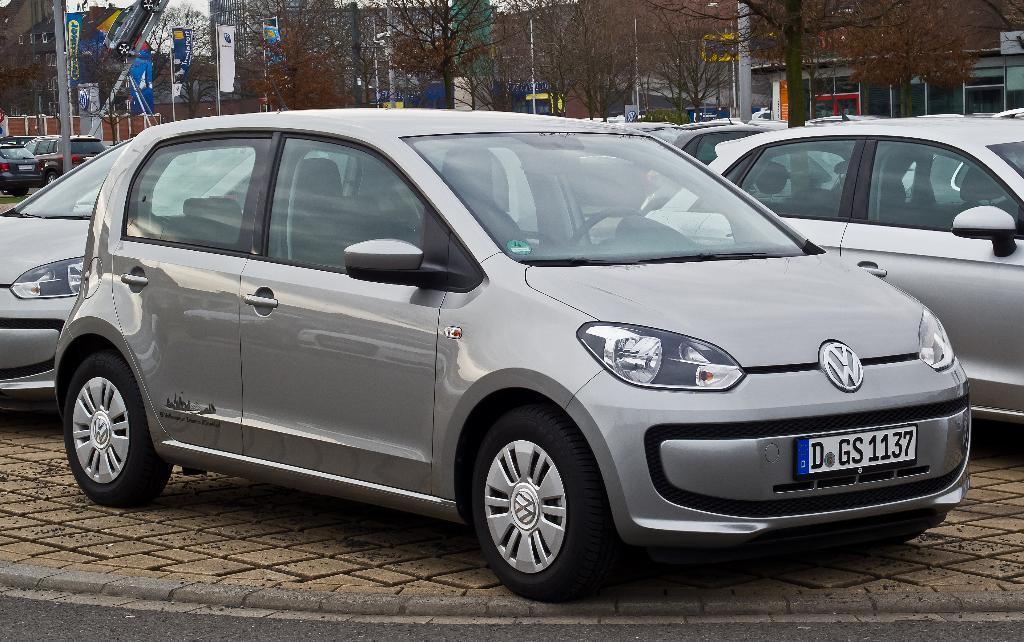How would you summarize this image in a sentence or two? In this image I can see few vehicles. In the background I can see few banners attached to the poles, few trees, buildings and the sky is in white color. 